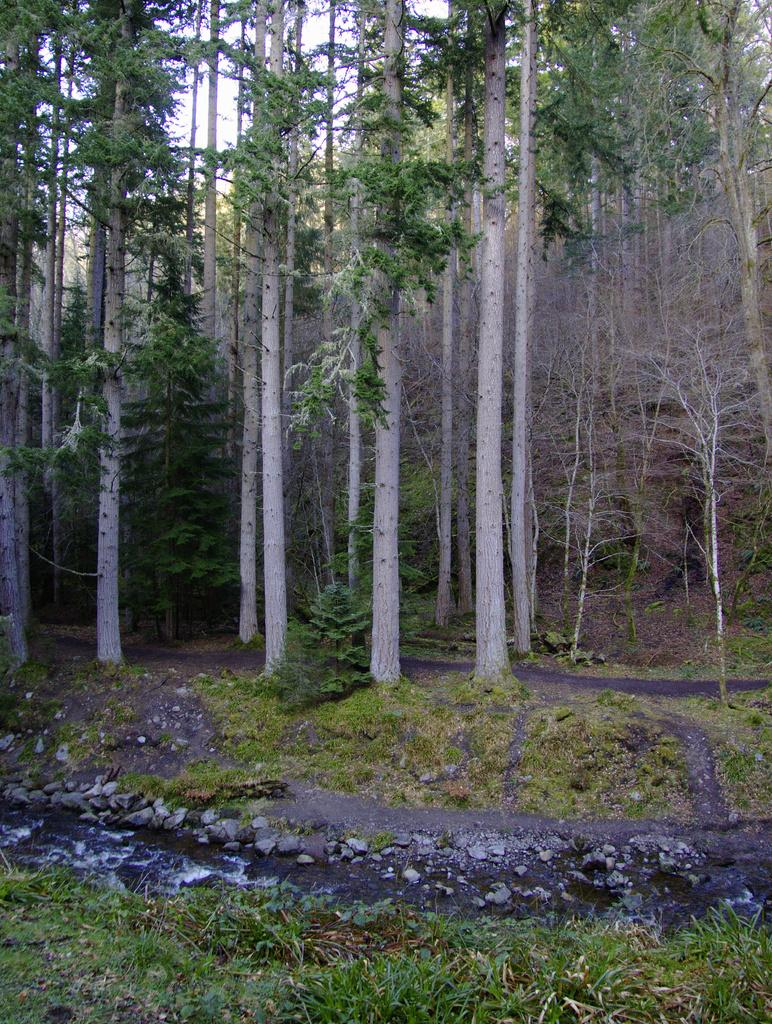What type of vegetation can be seen in the image? There are trees in the image. What else can be seen besides trees? There is water and grass visible in the image. What part of the natural environment is visible in the image? The sky is visible in the image. What type of coat is hanging on the tree in the image? There is no coat present in the image; it features trees, water, grass, and the sky. What kind of machine can be seen operating in the background of the image? There is no machine present in the image; it only contains trees, water, grass, and the sky. 